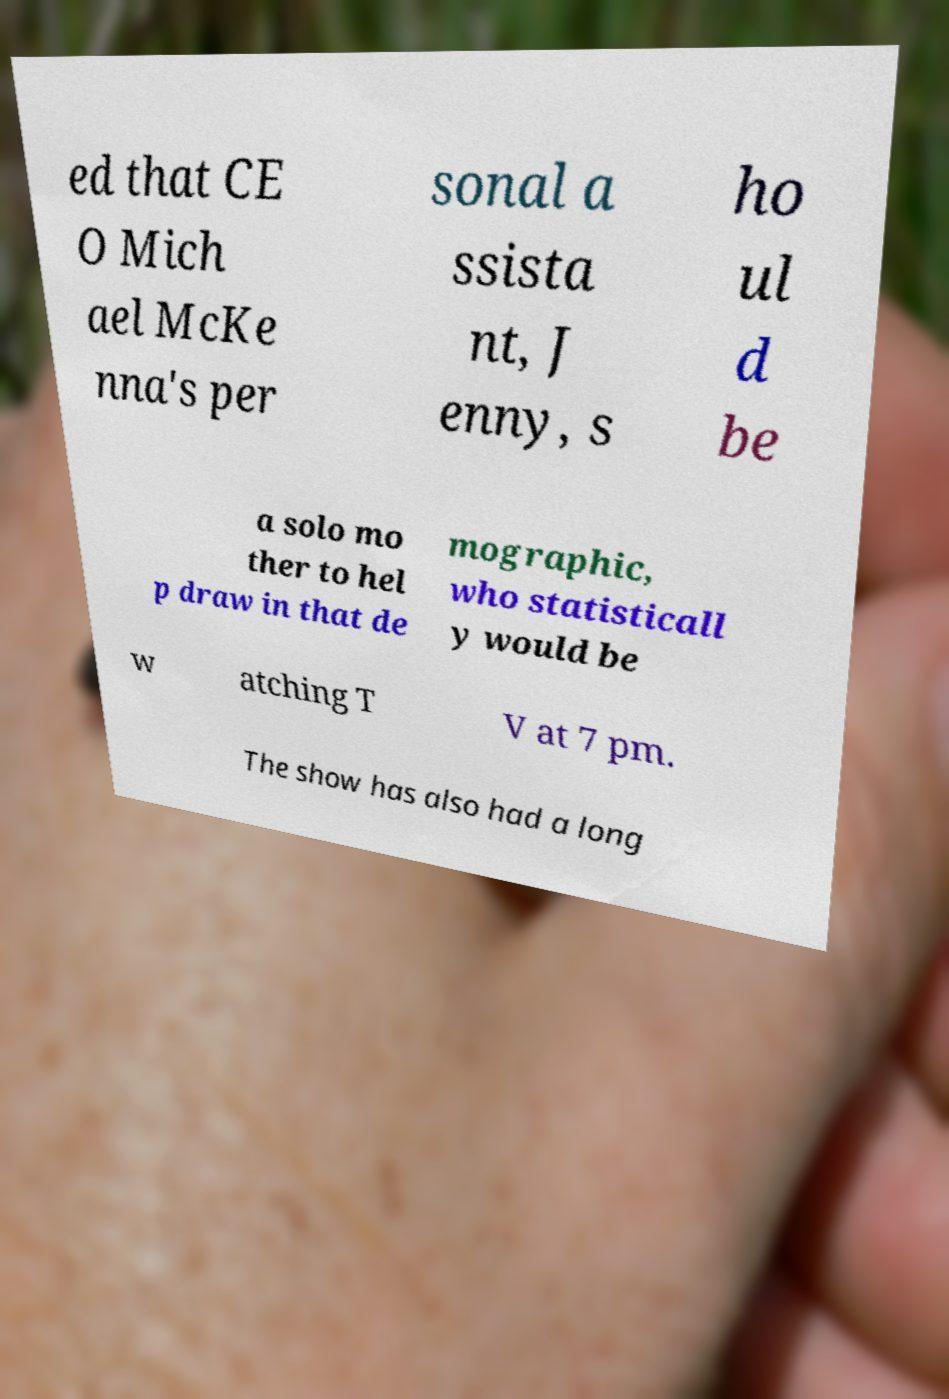Could you extract and type out the text from this image? ed that CE O Mich ael McKe nna's per sonal a ssista nt, J enny, s ho ul d be a solo mo ther to hel p draw in that de mographic, who statisticall y would be w atching T V at 7 pm. The show has also had a long 